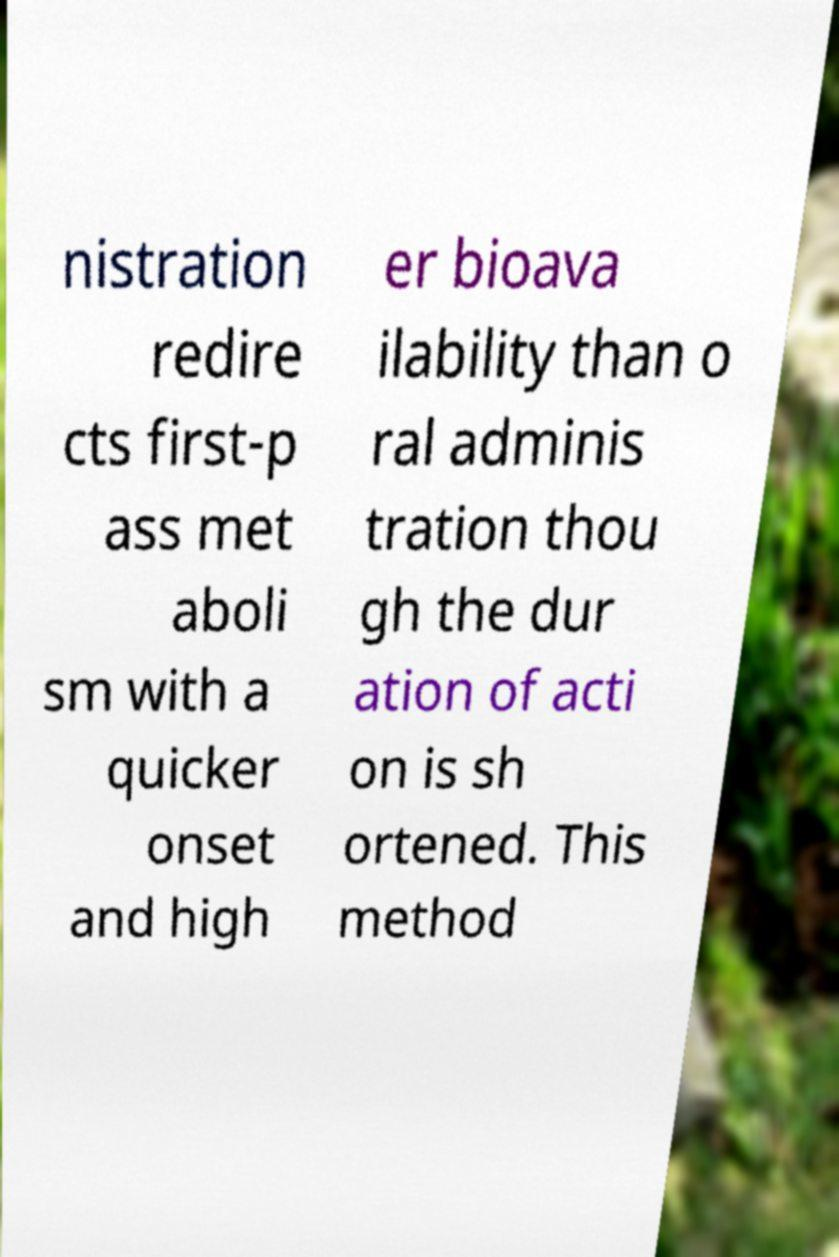What messages or text are displayed in this image? I need them in a readable, typed format. nistration redire cts first-p ass met aboli sm with a quicker onset and high er bioava ilability than o ral adminis tration thou gh the dur ation of acti on is sh ortened. This method 